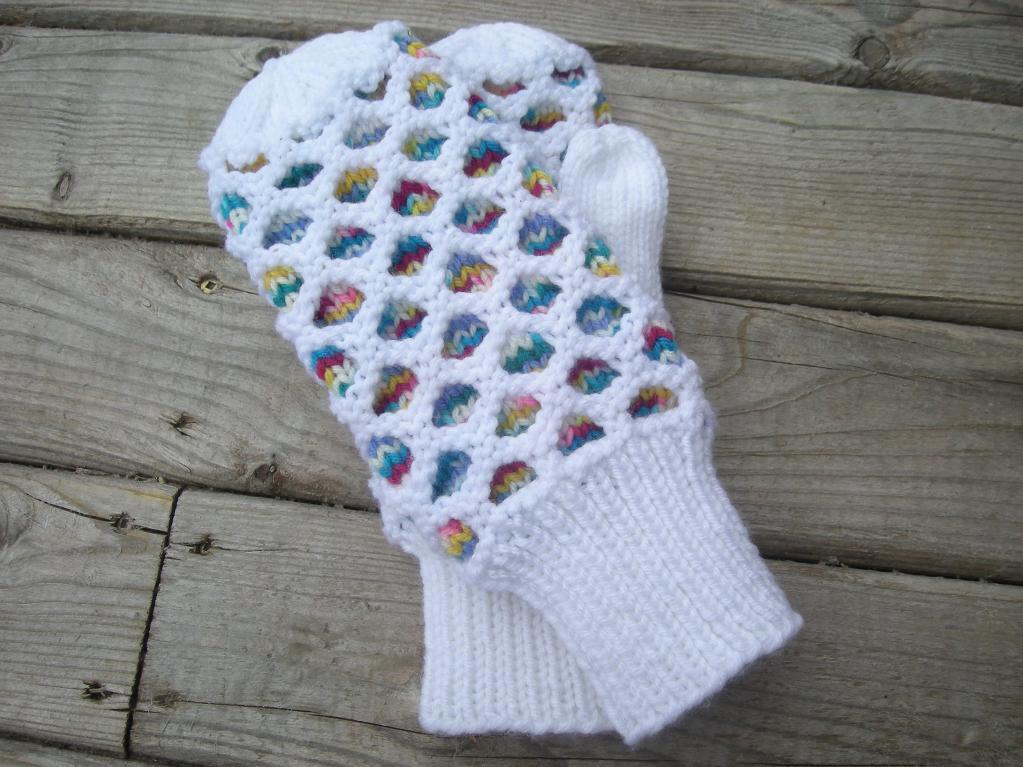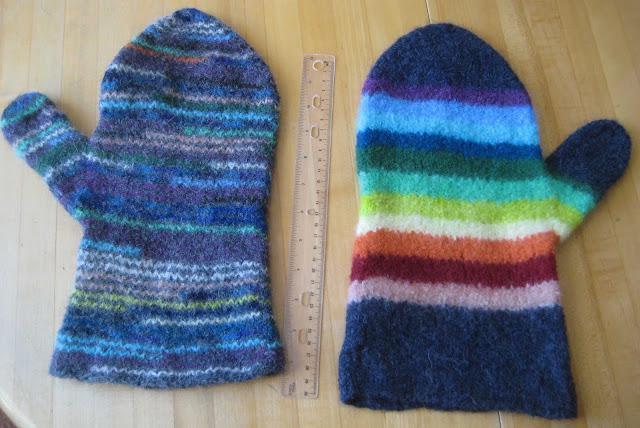The first image is the image on the left, the second image is the image on the right. Evaluate the accuracy of this statement regarding the images: "More than half of a mitten is covered by another mitten.". Is it true? Answer yes or no. Yes. The first image is the image on the left, the second image is the image on the right. Analyze the images presented: Is the assertion "Both images have gloves over a white background." valid? Answer yes or no. No. 